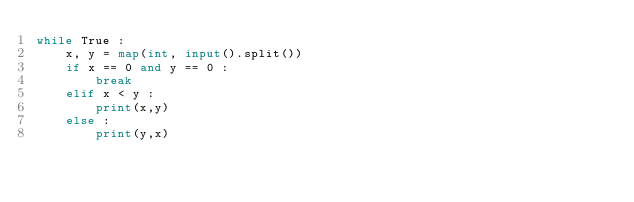Convert code to text. <code><loc_0><loc_0><loc_500><loc_500><_Python_>while True :
    x, y = map(int, input().split())
    if x == 0 and y == 0 :
        break
    elif x < y :
        print(x,y)
    else :
        print(y,x)
</code> 